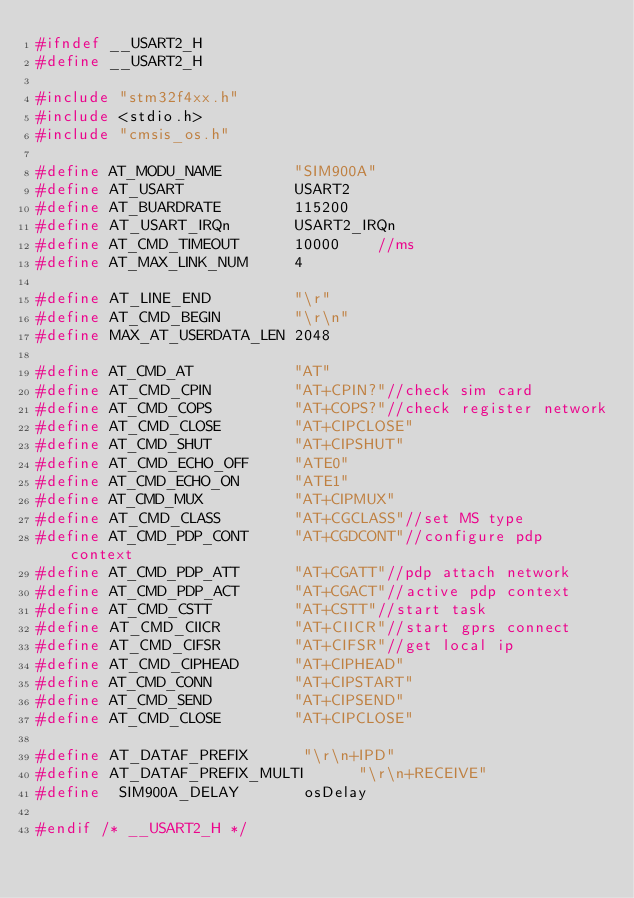<code> <loc_0><loc_0><loc_500><loc_500><_C_>#ifndef __USART2_H
#define	__USART2_H

#include "stm32f4xx.h"
#include <stdio.h>
#include "cmsis_os.h"

#define AT_MODU_NAME    	"SIM900A"
#define AT_USART   			USART2
#define AT_BUARDRATE   		115200
#define AT_USART_IRQn   	USART2_IRQn
#define AT_CMD_TIMEOUT		10000    //ms
#define AT_MAX_LINK_NUM     4

#define AT_LINE_END 		"\r"
#define AT_CMD_BEGIN		"\r\n"
#define MAX_AT_USERDATA_LEN 2048

#define AT_CMD_AT    		"AT"
#define AT_CMD_CPIN         "AT+CPIN?"//check sim card
#define AT_CMD_COPS         "AT+COPS?"//check register network
#define AT_CMD_CLOSE    	"AT+CIPCLOSE"
#define AT_CMD_SHUT    		"AT+CIPSHUT"
#define AT_CMD_ECHO_OFF 	"ATE0"
#define AT_CMD_ECHO_ON  	"ATE1"
#define AT_CMD_MUX 			"AT+CIPMUX"
#define AT_CMD_CLASS        "AT+CGCLASS"//set MS type
#define AT_CMD_PDP_CONT   	"AT+CGDCONT"//configure pdp context
#define AT_CMD_PDP_ATT    	"AT+CGATT"//pdp attach network
#define AT_CMD_PDP_ACT		"AT+CGACT"//active pdp context
#define AT_CMD_CSTT			"AT+CSTT"//start task
#define AT_CMD_CIICR		"AT+CIICR"//start gprs connect
#define AT_CMD_CIFSR		"AT+CIFSR"//get local ip
#define AT_CMD_CIPHEAD		"AT+CIPHEAD"
#define AT_CMD_CONN			"AT+CIPSTART"
#define AT_CMD_SEND			"AT+CIPSEND"
#define AT_CMD_CLOSE		"AT+CIPCLOSE"

#define AT_DATAF_PREFIX      "\r\n+IPD"
#define AT_DATAF_PREFIX_MULTI      "\r\n+RECEIVE"
#define  SIM900A_DELAY       osDelay

#endif /* __USART2_H */

</code> 